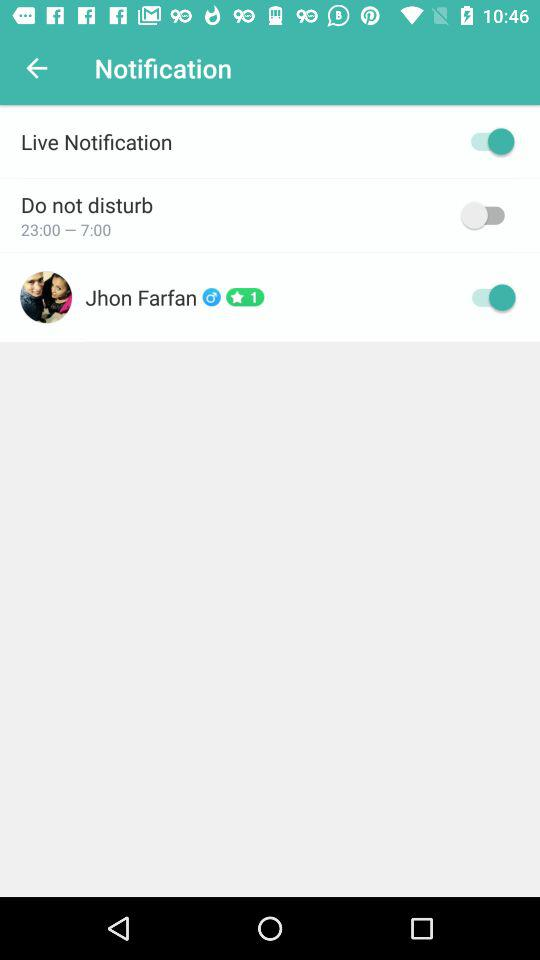What is the status of the live notification? The status is on. 